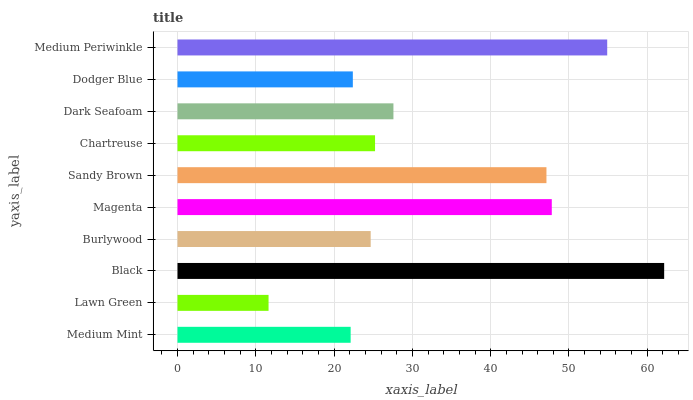Is Lawn Green the minimum?
Answer yes or no. Yes. Is Black the maximum?
Answer yes or no. Yes. Is Black the minimum?
Answer yes or no. No. Is Lawn Green the maximum?
Answer yes or no. No. Is Black greater than Lawn Green?
Answer yes or no. Yes. Is Lawn Green less than Black?
Answer yes or no. Yes. Is Lawn Green greater than Black?
Answer yes or no. No. Is Black less than Lawn Green?
Answer yes or no. No. Is Dark Seafoam the high median?
Answer yes or no. Yes. Is Chartreuse the low median?
Answer yes or no. Yes. Is Magenta the high median?
Answer yes or no. No. Is Medium Mint the low median?
Answer yes or no. No. 